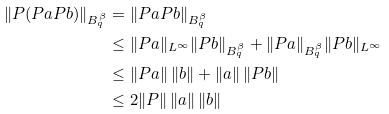Convert formula to latex. <formula><loc_0><loc_0><loc_500><loc_500>\| P ( P a P b ) \| _ { B _ { q } ^ { \beta } } & = \| P a P b \| _ { B _ { q } ^ { \beta } } \\ & \leq \| P a \| _ { L ^ { \infty } } \| P b \| _ { B _ { q } ^ { \beta } } + \| P a \| _ { B _ { q } ^ { \beta } } \| P b \| _ { L ^ { \infty } } \\ & \leq \| P a \| \, \| b \| + \| a \| \, \| P b \| \\ & \leq 2 \| P \| \, \| a \| \, \| b \|</formula> 